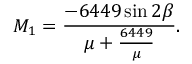Convert formula to latex. <formula><loc_0><loc_0><loc_500><loc_500>M _ { 1 } = \frac { - 6 4 4 9 \sin 2 \beta } { \mu + \frac { 6 4 4 9 } { \mu } } .</formula> 